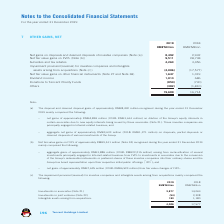According to Tencent's financial document, How much is the 2019 subsidies and tax rebates? According to the financial document, 4,263 (in millions). The relevant text states: "Subsidies and tax rebates 4,263 3,456..." Also, How much is the 2018 subsidies and tax rebates? According to the financial document, 3,456 (in millions). The relevant text states: "Subsidies and tax rebates 4,263 3,456..." Also, How much is the 2019 dividend income? According to the financial document, 1,014 (in millions). The relevant text states: "Dividend income 1,014 686..." Also, can you calculate: What is the change in Net fair value gains on FVPL from 2018 to 2019? Based on the calculation: 9,511-28,738, the result is -19227 (in millions). This is based on the information: "Net fair value gains on FVPL (Note (b)) 9,511 28,738 Net fair value gains on FVPL (Note (b)) 9,511 28,738..." The key data points involved are: 28,738, 9,511. Also, can you calculate: What is the change in subsidies and tax rebates from 2018 to 2019? Based on the calculation: 4,263-3,456, the result is 807 (in millions). This is based on the information: "Subsidies and tax rebates 4,263 3,456 Subsidies and tax rebates 4,263 3,456..." The key data points involved are: 3,456, 4,263. Also, can you calculate: What is the change in dividend income from 2018 to 2019? Based on the calculation: 1,014-686, the result is 328 (in millions). This is based on the information: "Dividend income 1,014 686 Dividend income 1,014 686..." The key data points involved are: 1,014, 686. 